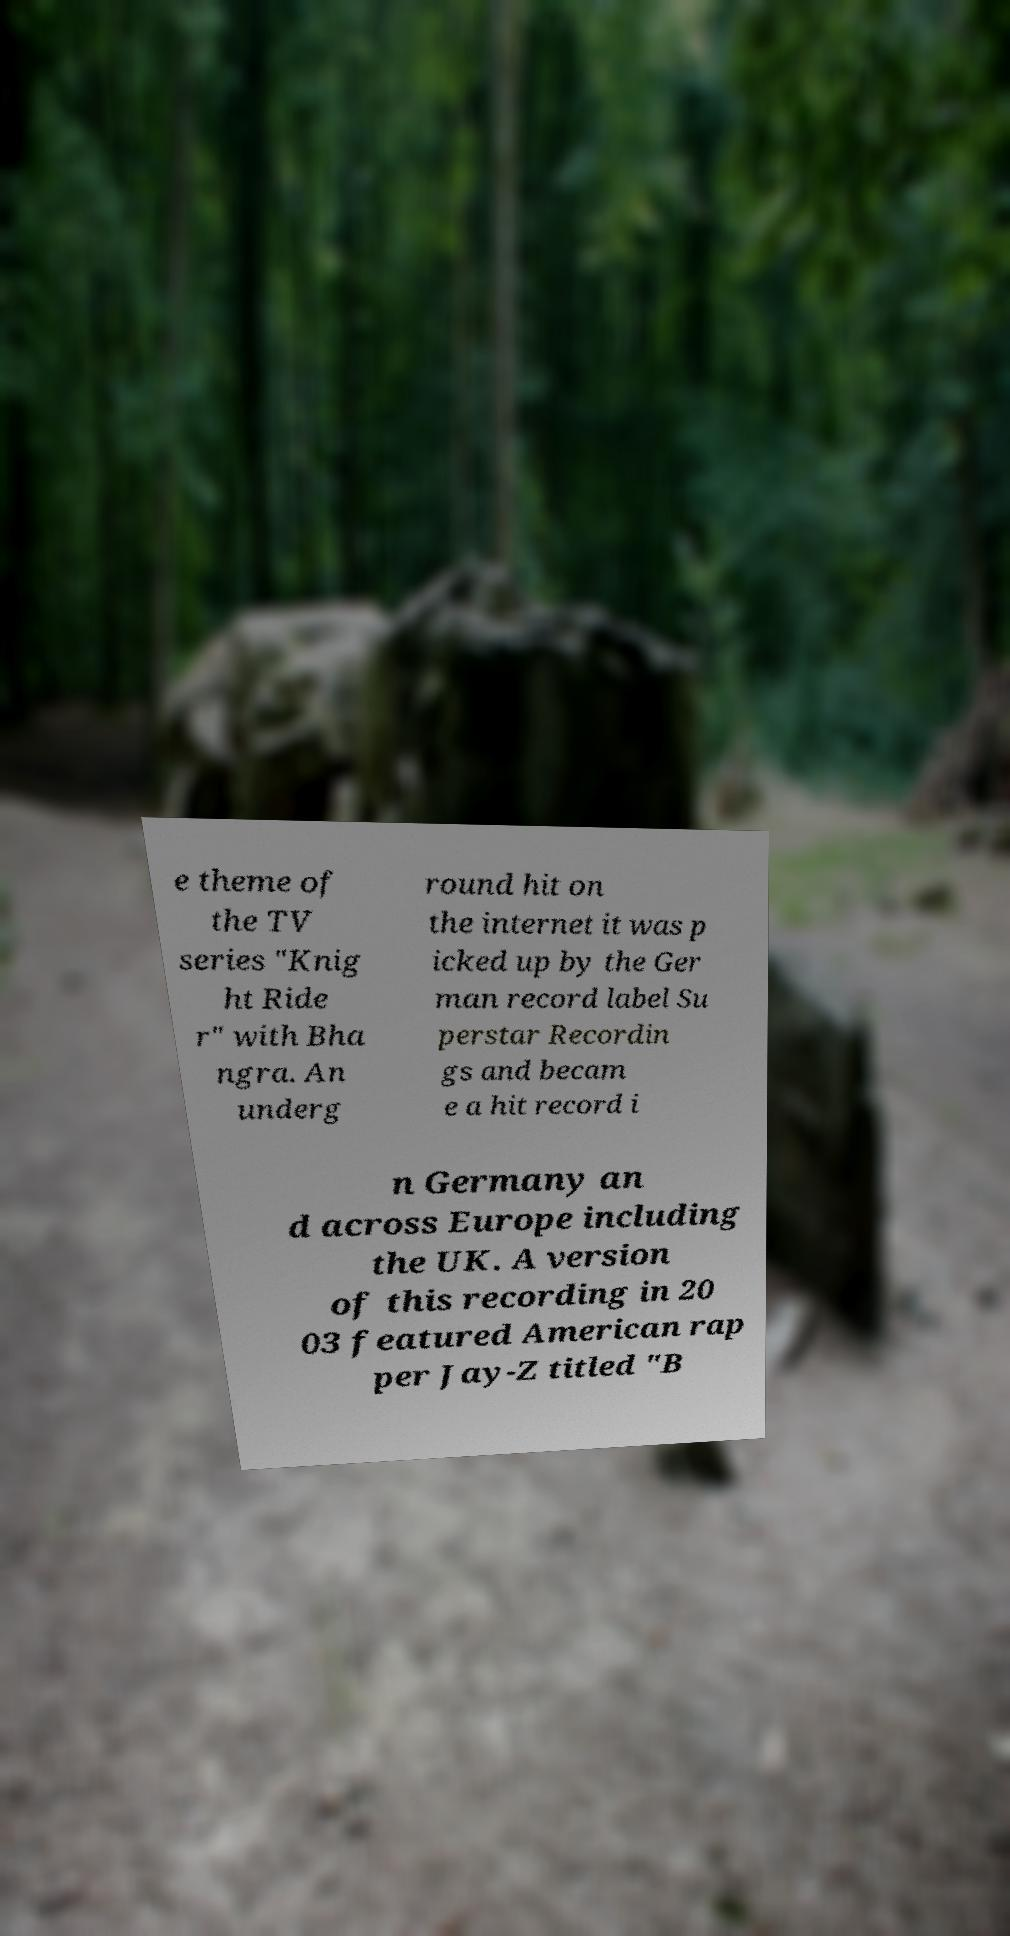Please identify and transcribe the text found in this image. e theme of the TV series "Knig ht Ride r" with Bha ngra. An underg round hit on the internet it was p icked up by the Ger man record label Su perstar Recordin gs and becam e a hit record i n Germany an d across Europe including the UK. A version of this recording in 20 03 featured American rap per Jay-Z titled "B 